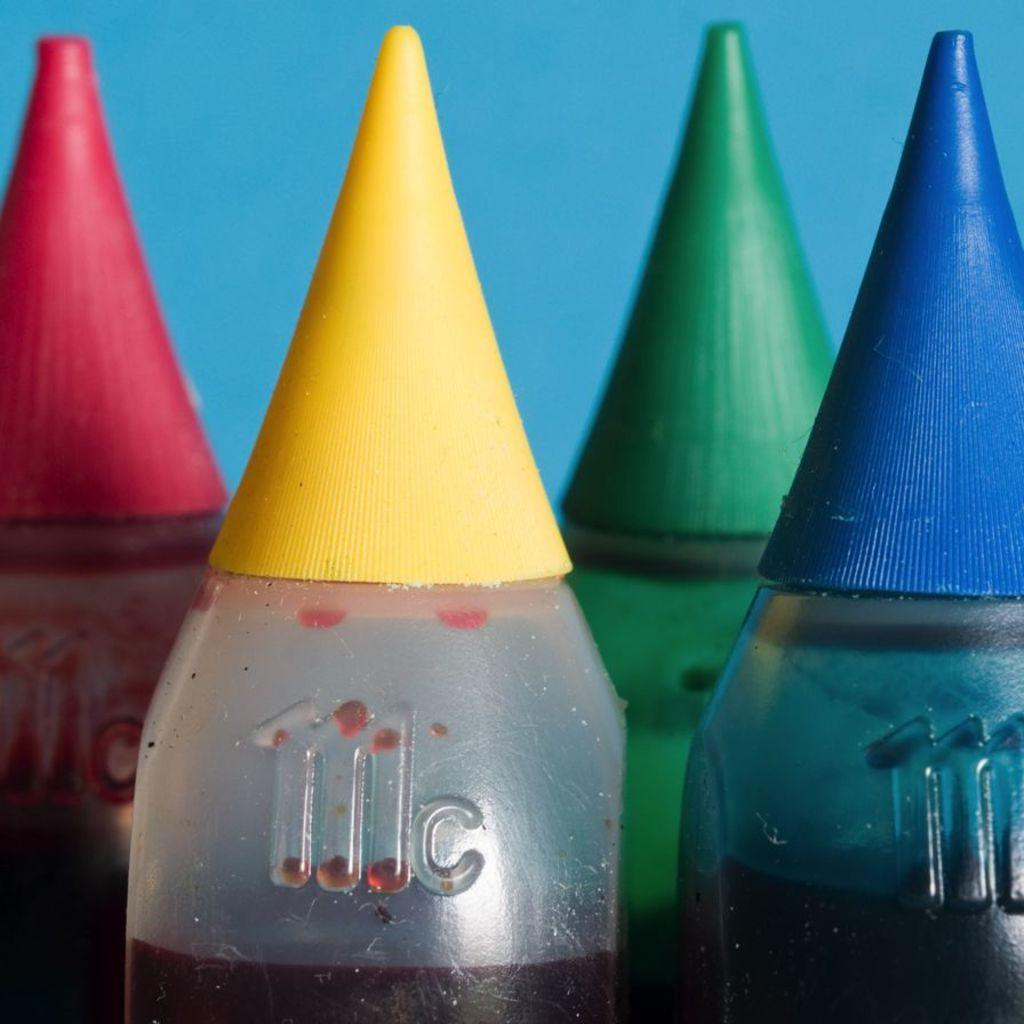What type of bottles are present in the image? There are ink bottles in the image. What is the purpose of these ink bottles? The ink bottles are for a printer. What colors are the ink bottles available in? The ink bottles are in yellow, green, blue, and pink colors. What company is the secretary working for in the image? There is no secretary or company present in the image; it only features ink bottles for a printer. 